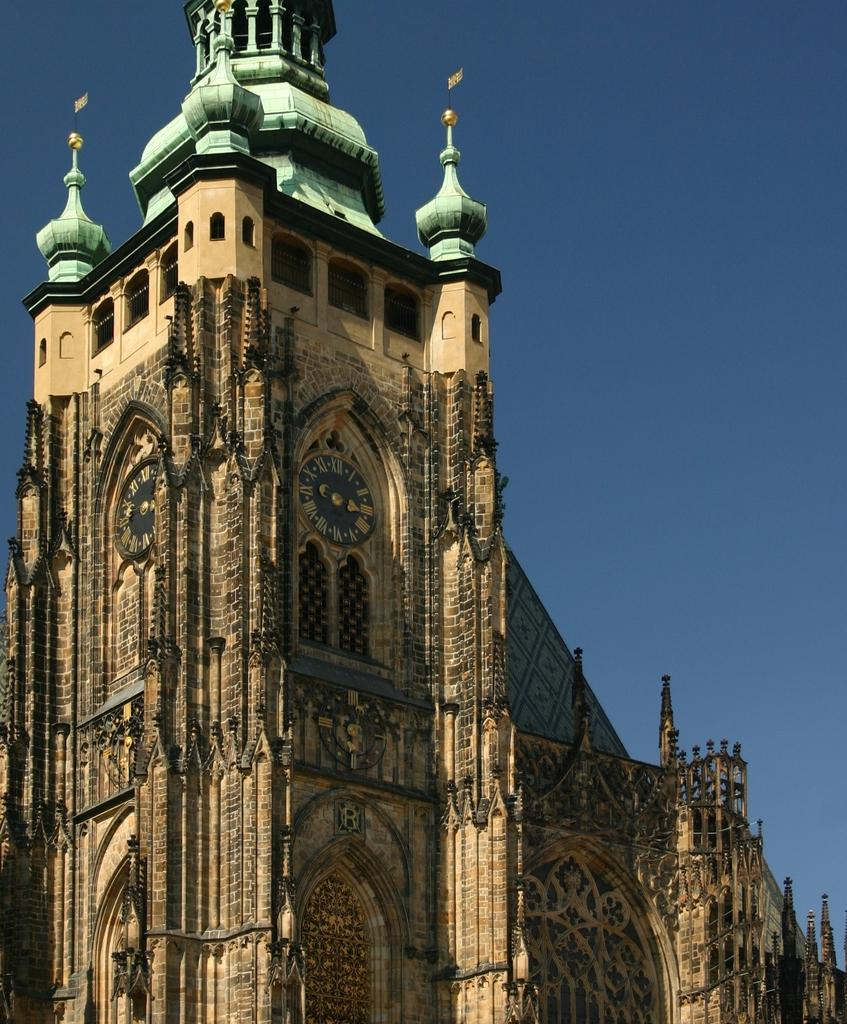What type of structure is present in the image? There is a building in the image. What features can be seen on the building? There are clocks on the building. What additional elements are present in the image? There are flags in the image. What can be seen in the background of the image? The sky is visible in the background of the image. What is the color of the background in the image? The background of the image is blue in color. How many beds can be seen in the image? There are no beds present in the image. What type of jar is visible on the building? There is no jar visible on the building in the image. 